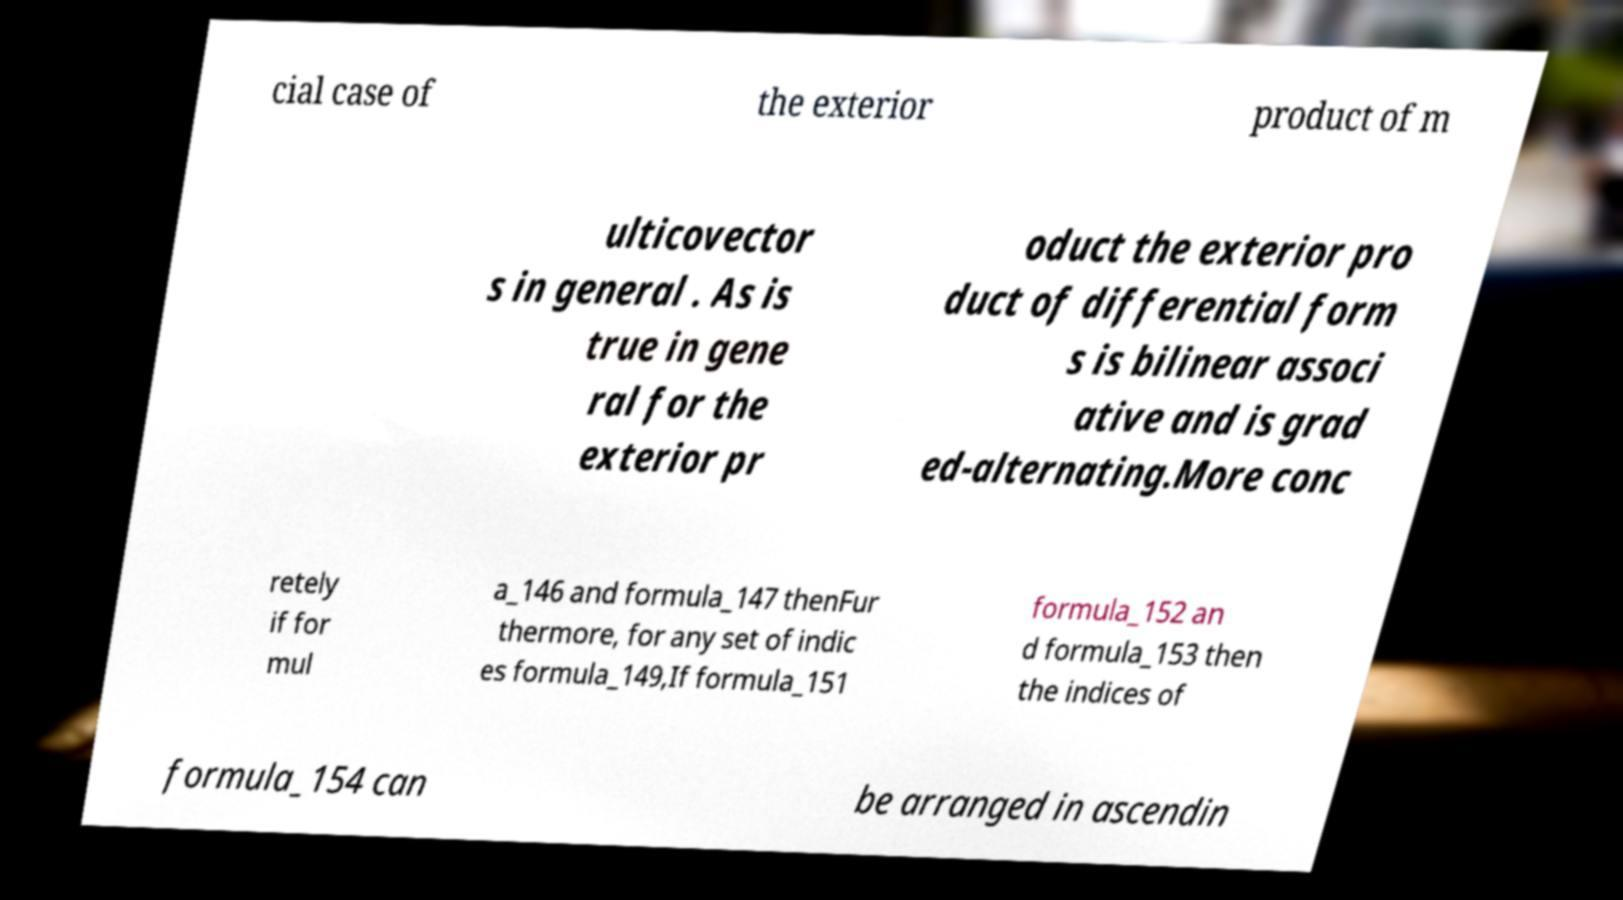Could you extract and type out the text from this image? cial case of the exterior product of m ulticovector s in general . As is true in gene ral for the exterior pr oduct the exterior pro duct of differential form s is bilinear associ ative and is grad ed-alternating.More conc retely if for mul a_146 and formula_147 thenFur thermore, for any set of indic es formula_149,If formula_151 formula_152 an d formula_153 then the indices of formula_154 can be arranged in ascendin 